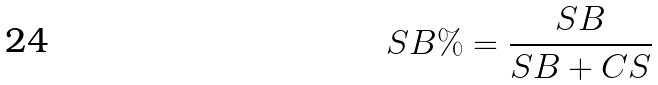<formula> <loc_0><loc_0><loc_500><loc_500>S B \% = \frac { S B } { S B + C S }</formula> 